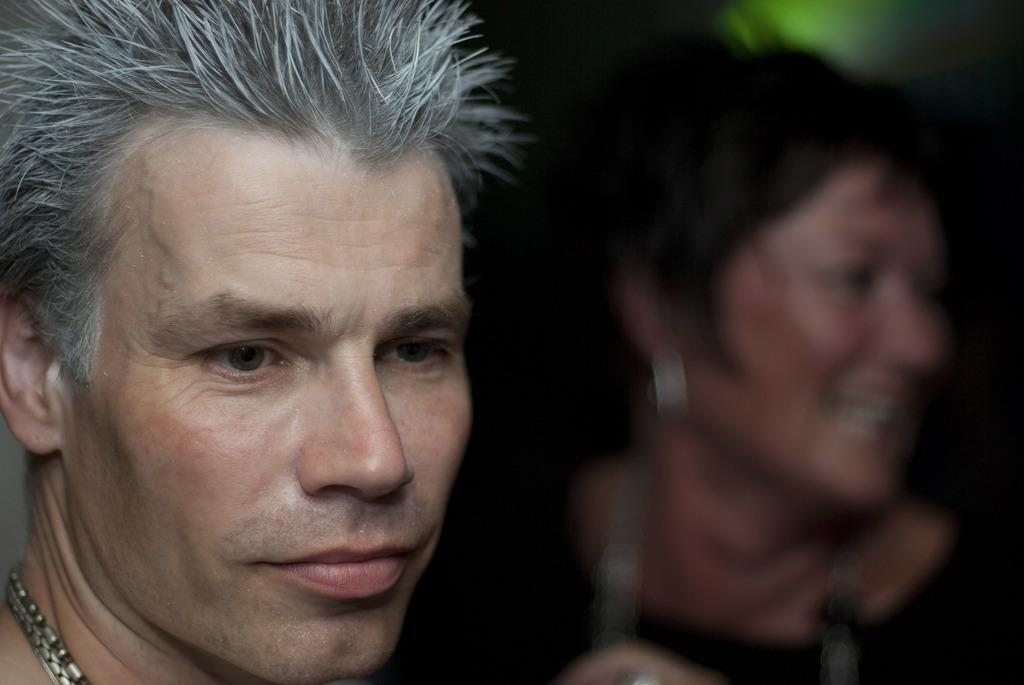How many people are in the image? There are two persons in the image. What is the facial expression of the people in the image? The two persons are smiling. What type of tank can be seen in the image? There is no tank present in the image; it features two smiling persons. How long can the persons rest in the image? The image does not depict the persons resting, nor does it provide information about the duration of any potential rest. 